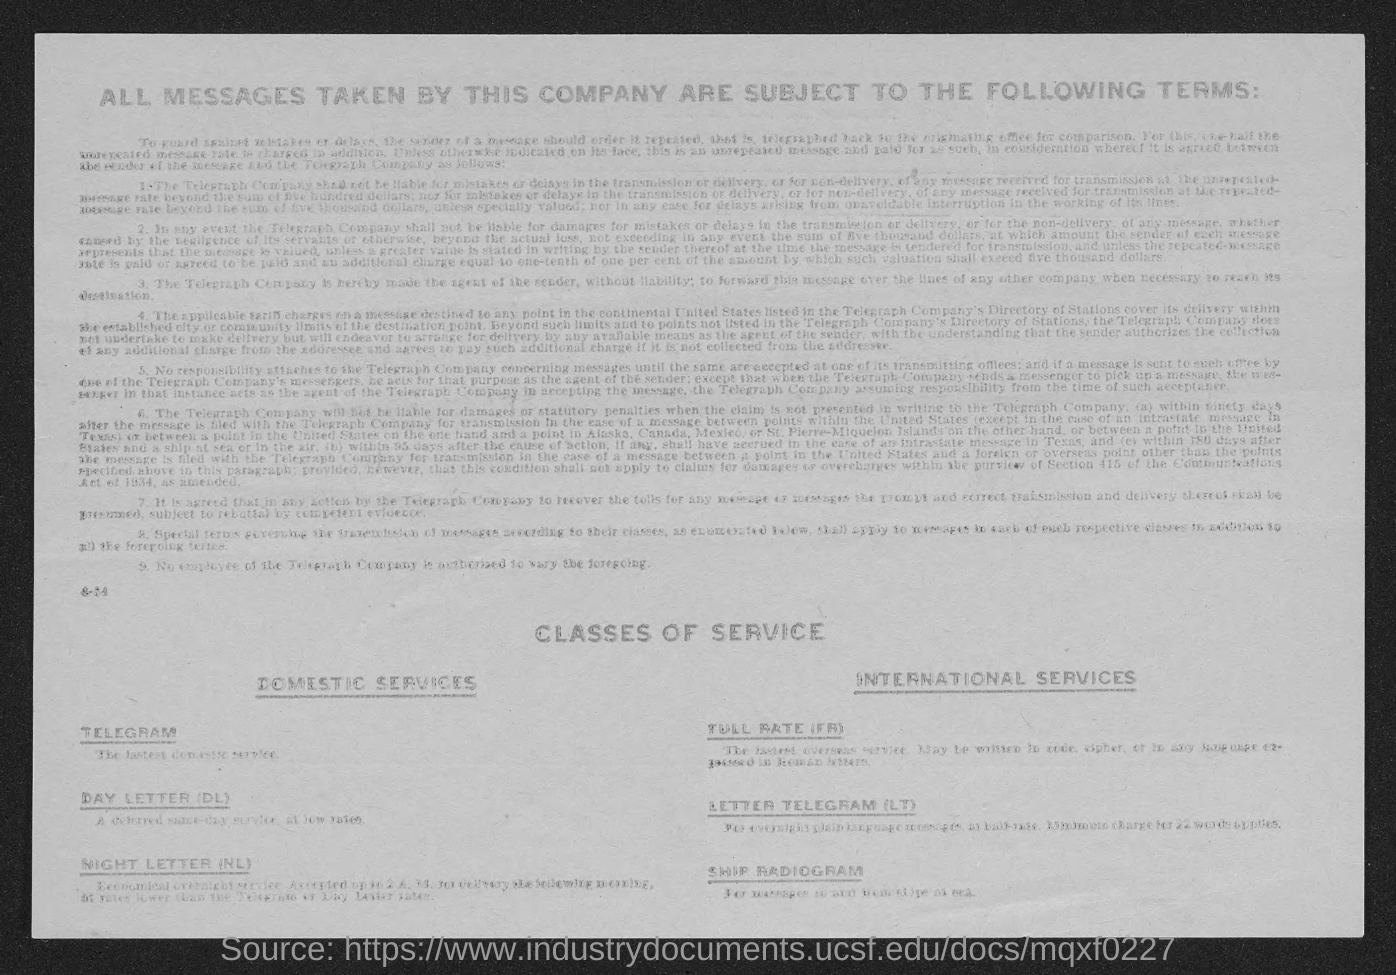Outline some significant characteristics in this image. The letter Telegram falls under the category of international services. Telegram is classified as a domestic service. What does DL stand for?" is a question asking for an explanation or definition of a set of initials. "Day letter" is a possible answer, suggesting that DL may be an abbreviation for a combination of the words "day" and "letter. 